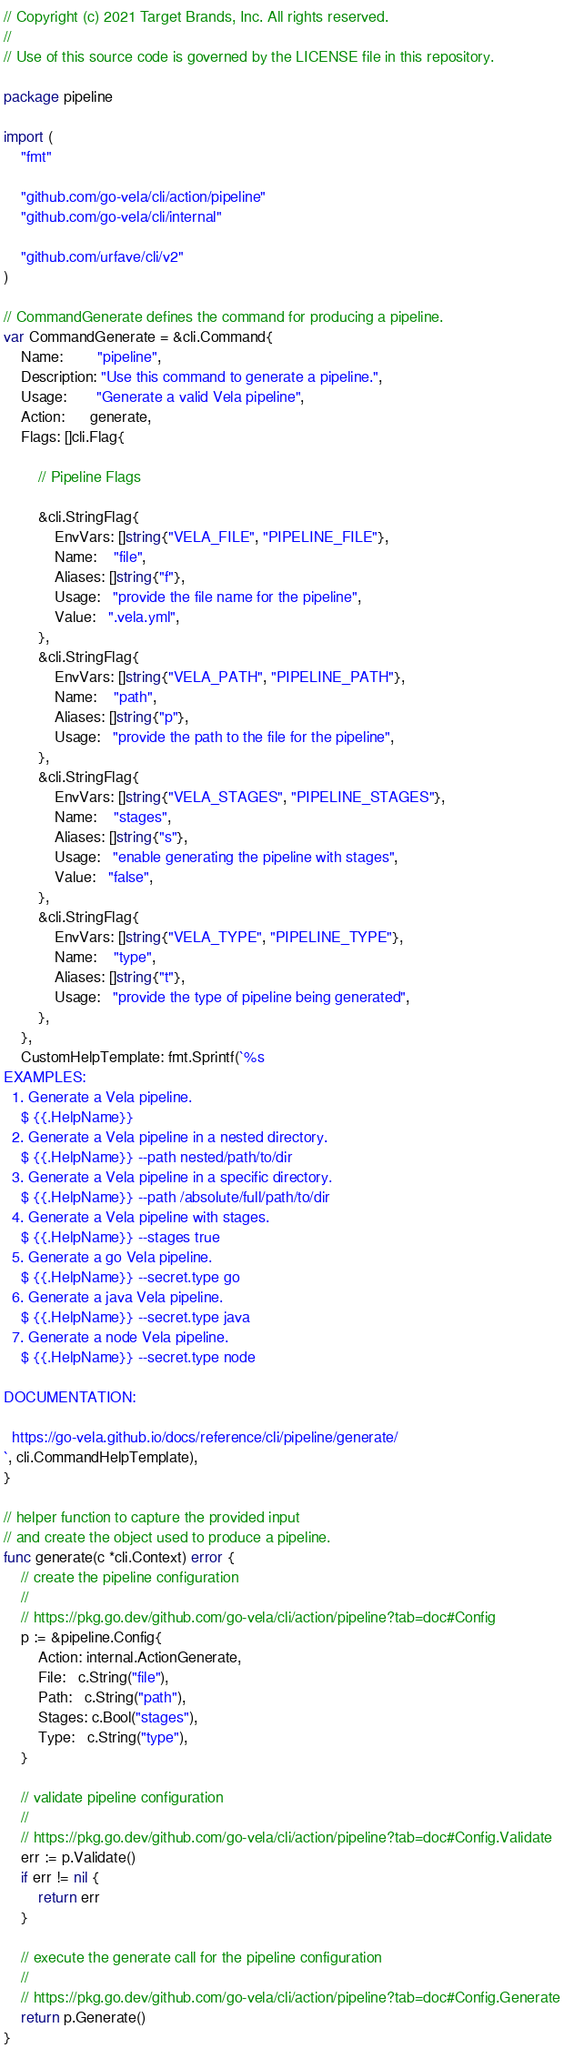<code> <loc_0><loc_0><loc_500><loc_500><_Go_>// Copyright (c) 2021 Target Brands, Inc. All rights reserved.
//
// Use of this source code is governed by the LICENSE file in this repository.

package pipeline

import (
	"fmt"

	"github.com/go-vela/cli/action/pipeline"
	"github.com/go-vela/cli/internal"

	"github.com/urfave/cli/v2"
)

// CommandGenerate defines the command for producing a pipeline.
var CommandGenerate = &cli.Command{
	Name:        "pipeline",
	Description: "Use this command to generate a pipeline.",
	Usage:       "Generate a valid Vela pipeline",
	Action:      generate,
	Flags: []cli.Flag{

		// Pipeline Flags

		&cli.StringFlag{
			EnvVars: []string{"VELA_FILE", "PIPELINE_FILE"},
			Name:    "file",
			Aliases: []string{"f"},
			Usage:   "provide the file name for the pipeline",
			Value:   ".vela.yml",
		},
		&cli.StringFlag{
			EnvVars: []string{"VELA_PATH", "PIPELINE_PATH"},
			Name:    "path",
			Aliases: []string{"p"},
			Usage:   "provide the path to the file for the pipeline",
		},
		&cli.StringFlag{
			EnvVars: []string{"VELA_STAGES", "PIPELINE_STAGES"},
			Name:    "stages",
			Aliases: []string{"s"},
			Usage:   "enable generating the pipeline with stages",
			Value:   "false",
		},
		&cli.StringFlag{
			EnvVars: []string{"VELA_TYPE", "PIPELINE_TYPE"},
			Name:    "type",
			Aliases: []string{"t"},
			Usage:   "provide the type of pipeline being generated",
		},
	},
	CustomHelpTemplate: fmt.Sprintf(`%s
EXAMPLES:
  1. Generate a Vela pipeline.
    $ {{.HelpName}}
  2. Generate a Vela pipeline in a nested directory.
    $ {{.HelpName}} --path nested/path/to/dir
  3. Generate a Vela pipeline in a specific directory.
    $ {{.HelpName}} --path /absolute/full/path/to/dir
  4. Generate a Vela pipeline with stages.
    $ {{.HelpName}} --stages true
  5. Generate a go Vela pipeline.
    $ {{.HelpName}} --secret.type go
  6. Generate a java Vela pipeline.
    $ {{.HelpName}} --secret.type java
  7. Generate a node Vela pipeline.
    $ {{.HelpName}} --secret.type node

DOCUMENTATION:

  https://go-vela.github.io/docs/reference/cli/pipeline/generate/
`, cli.CommandHelpTemplate),
}

// helper function to capture the provided input
// and create the object used to produce a pipeline.
func generate(c *cli.Context) error {
	// create the pipeline configuration
	//
	// https://pkg.go.dev/github.com/go-vela/cli/action/pipeline?tab=doc#Config
	p := &pipeline.Config{
		Action: internal.ActionGenerate,
		File:   c.String("file"),
		Path:   c.String("path"),
		Stages: c.Bool("stages"),
		Type:   c.String("type"),
	}

	// validate pipeline configuration
	//
	// https://pkg.go.dev/github.com/go-vela/cli/action/pipeline?tab=doc#Config.Validate
	err := p.Validate()
	if err != nil {
		return err
	}

	// execute the generate call for the pipeline configuration
	//
	// https://pkg.go.dev/github.com/go-vela/cli/action/pipeline?tab=doc#Config.Generate
	return p.Generate()
}
</code> 